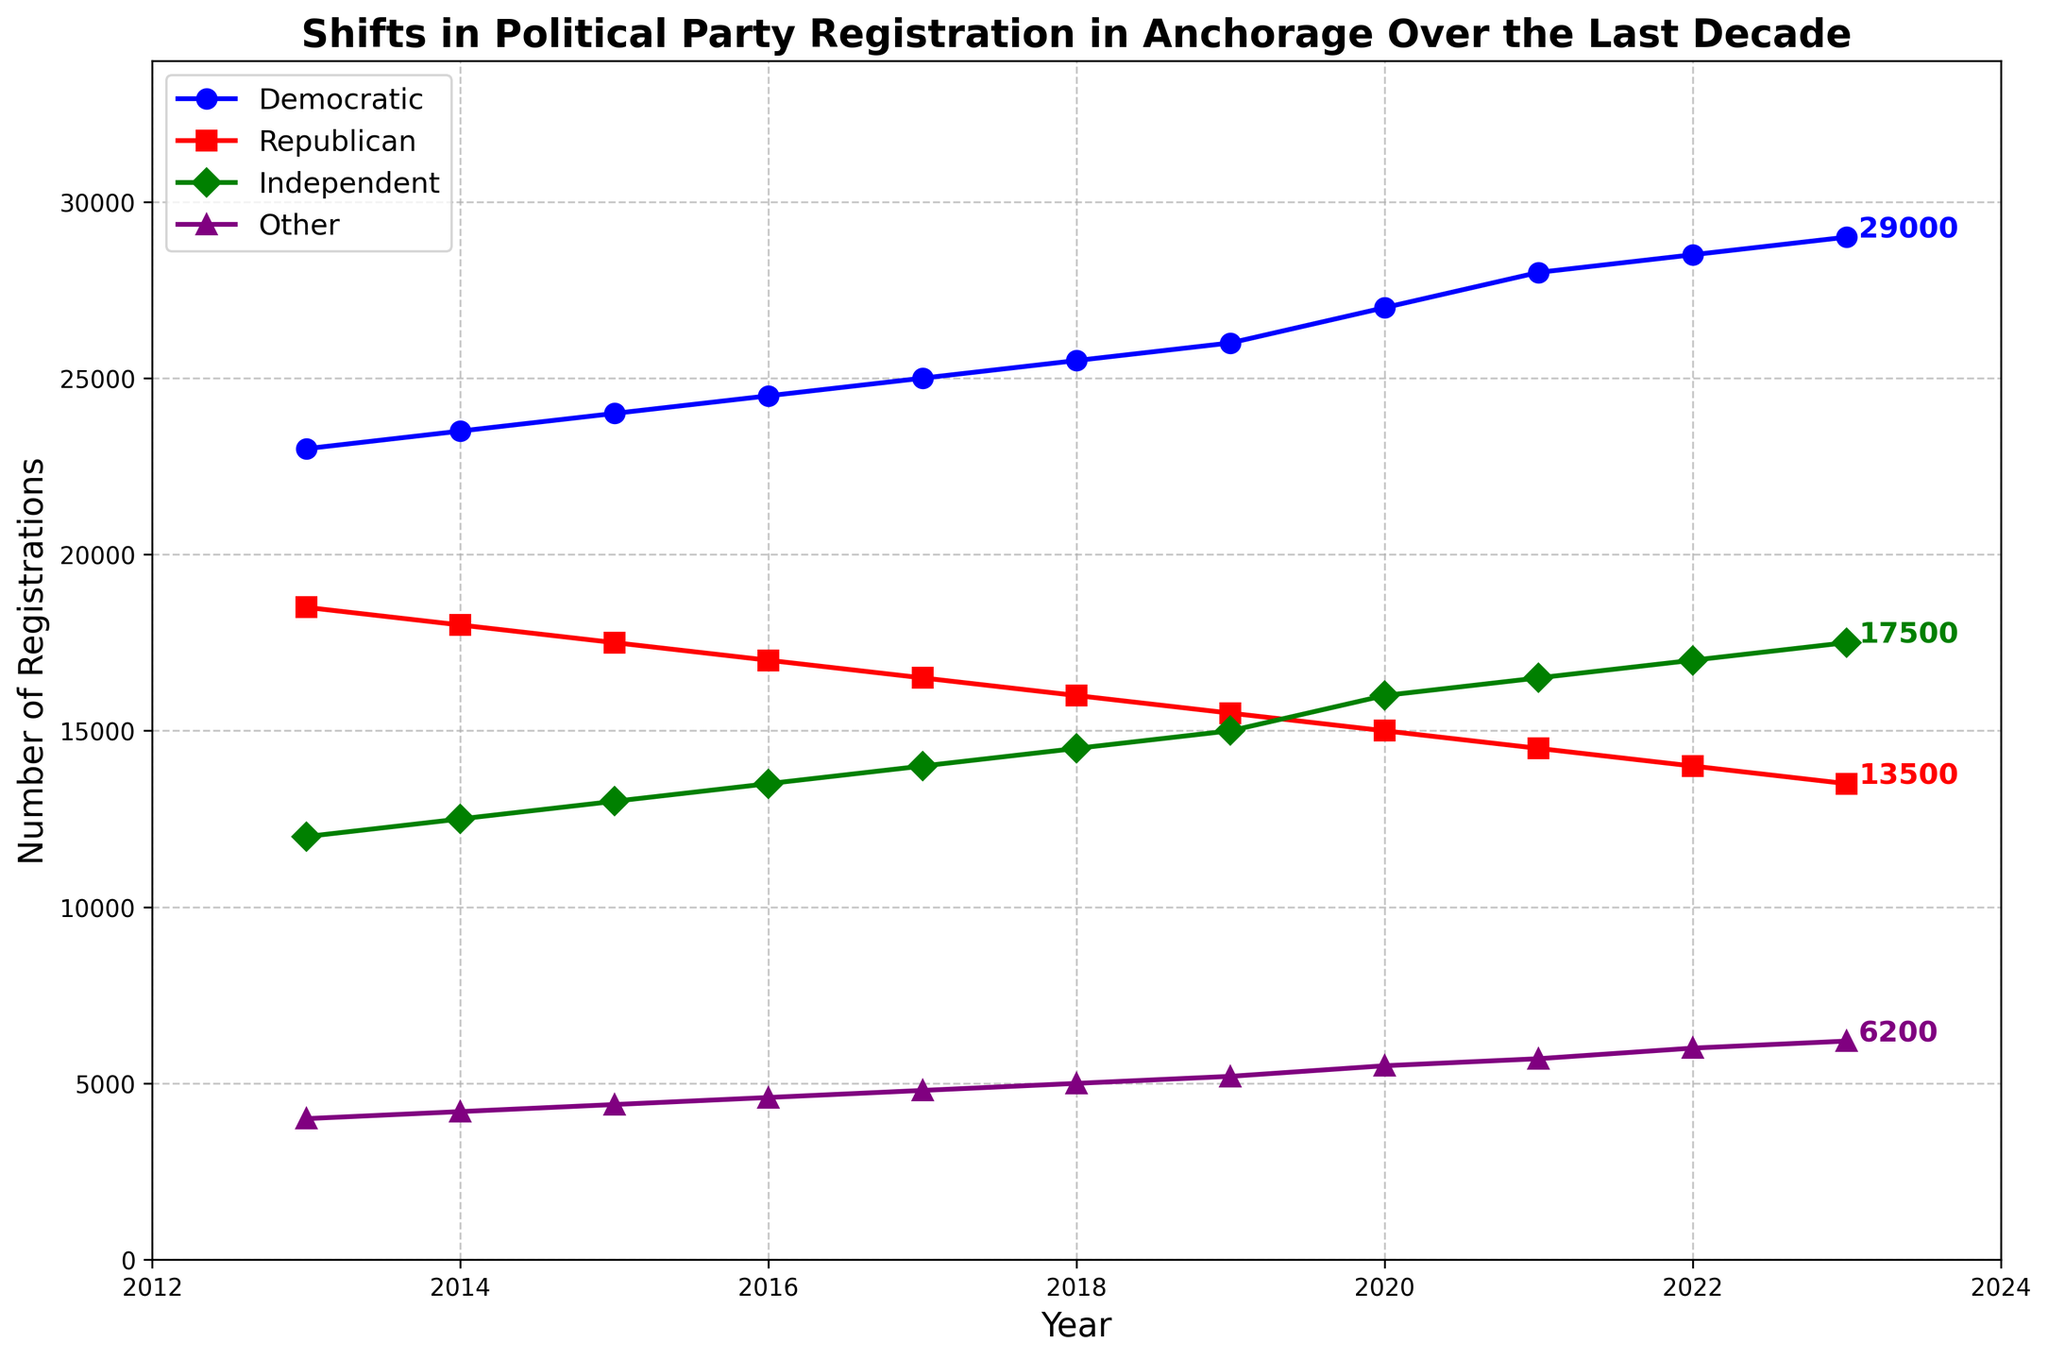What's the difference in Democratic and Republican registrations in 2023? To find the difference between Democratic and Republican registrations, look at the respective values for 2023 and subtract the Republican figure from the Democratic one. There are 29,000 Democratic registrations and 13,500 Republican registrations in 2023. The difference is 29,000 - 13,500 = 15,500.
Answer: 15,500 What was the total number of Independent and Other registrations in 2015? Add the number of Independent registrations (13,000) and Other registrations (4,400) for the year 2015. 13,000 + 4,400 = 17,400.
Answer: 17,400 Which party showed the greatest increase in registrations over the decade? To determine which party showed the greatest increase, calculate the difference in registrations from 2023 and 2013 for each party. The differences are: Democratic: 29,000 - 23,000 = 6,000; Republican: 13,500 - 18,500 = -5,000; Independent: 17,500 - 12,000 = 5,500; Other: 6,200 - 4,000 = 2,200. The Democratic Party showed the greatest increase.
Answer: Democratic By how much did the Independent registrations change from 2022 to 2023? Look at the Independent values for 2022 and 2023. The registrations in 2022 were 17,000 and in 2023 were 17,500. The change is 17,500 - 17,000 = 500.
Answer: 500 Which party consistently lost registrations each year? Observe the trend lines for each party. The Republican Party consistently lost registrations every year from 2013 to 2023.
Answer: Republican In what year did Independent registrations surpass Republican registrations? Analyze the plotted data for Independent and Republican registrations and identify the year when the number of Independent registrations first exceeds that of Republicans. In 2020, Independent (16,000) surpassed Republican (15,000) registrations.
Answer: 2020 What is the average Democratic registration over the decade? Sum the Democratic registration values from 2013 to 2023 and divide by the number of years (11). (23,000 + 23,500 + 24,000 + 24,500 + 25,000 + 25,500 + 26,000 + 27,000 + 28,000 + 28,500 + 29,000) = 275,000; 275,000 / 11 = 25,000.
Answer: 25,000 Which party had the smallest total registration increase over the decade? Calculate the total registration increase for each party by subtracting the 2013 registration from the 2023 registration. Democratic: 29,000 - 23,000 = 6,000; Republican: 13,500 - 18,500 = -5,000; Independent: 17,500 - 12,000 = 5,500; Other: 6,200 - 4,000 = 2,200. The Republican Party had the smallest increase (-5,000 showing a decrease).
Answer: Republican What is the difference in the number of registrations between Democratic and Independent in 2020? Find the number of registrations for both Democratic (27,000) and Independent (16,000) in 2020 and subtract the Independent figure from the Democratic one. 27,000 - 16,000 = 11,000.
Answer: 11,000 